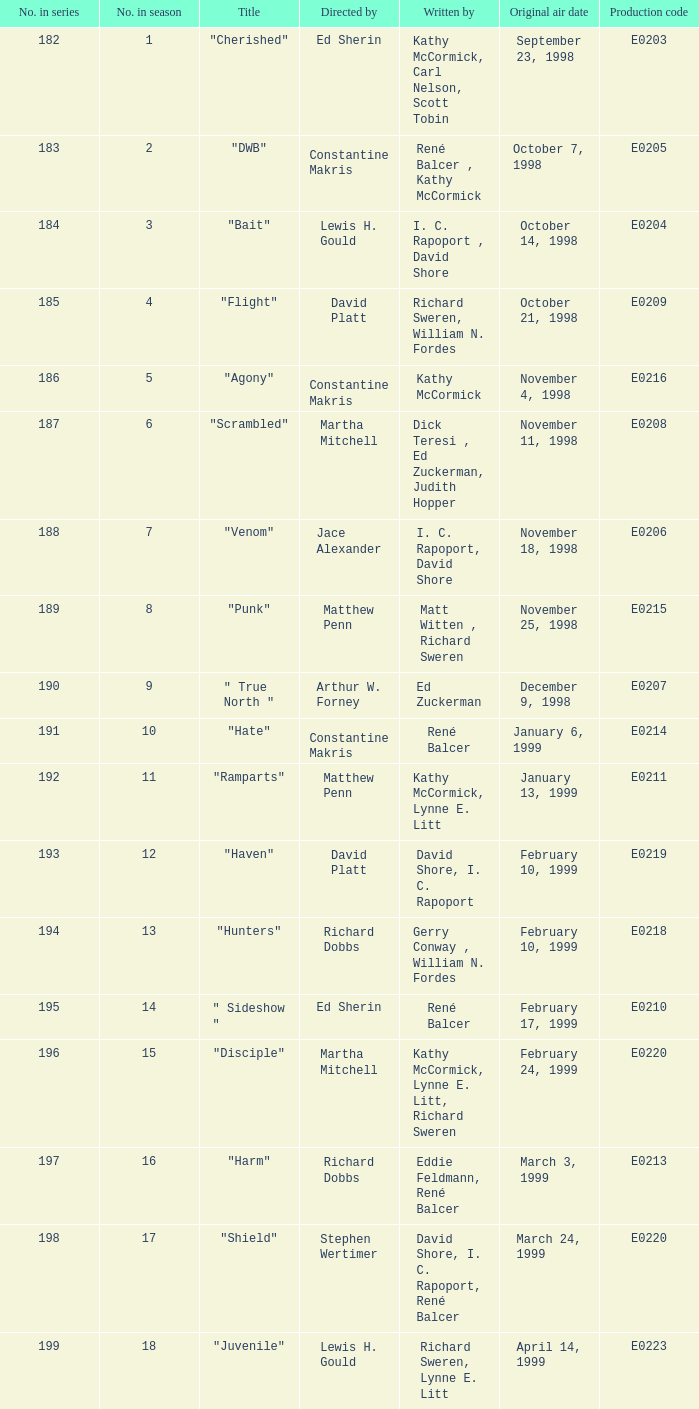The episode with the title "Bait" has what original air date? October 14, 1998. 